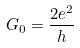<formula> <loc_0><loc_0><loc_500><loc_500>G _ { 0 } = \frac { 2 e ^ { 2 } } { h }</formula> 